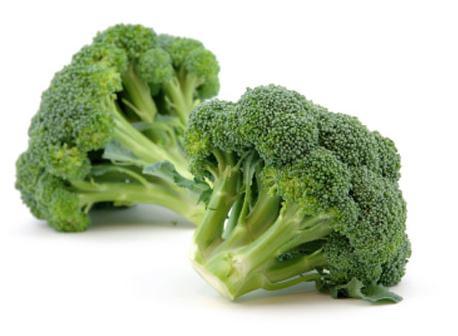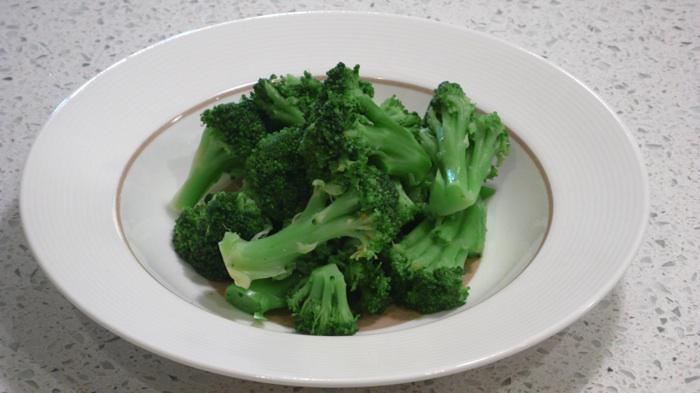The first image is the image on the left, the second image is the image on the right. For the images displayed, is the sentence "An image shows broccoli in a round container with one handle." factually correct? Answer yes or no. No. 